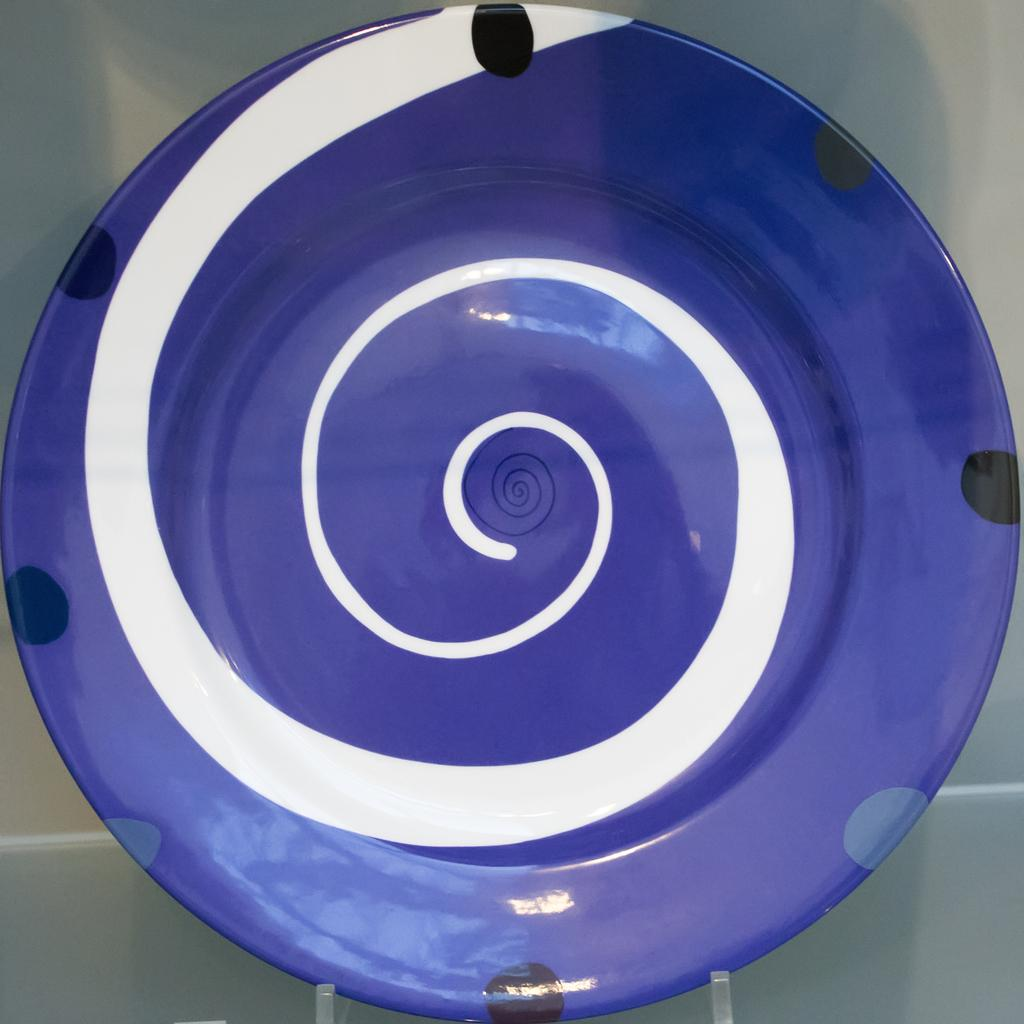What object is visible in the image? There is a plate in the image. Where is the plate located? The plate is placed on a table. What type of action is taking place in the scene involving a tray? There is no tray present in the image, and therefore no action involving a tray can be observed. 